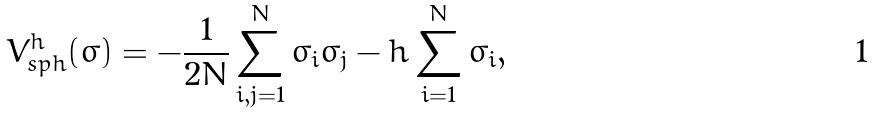<formula> <loc_0><loc_0><loc_500><loc_500>V ^ { h } _ { s p h } ( \sigma ) = - \frac { 1 } { 2 N } \sum _ { i , j = 1 } ^ { N } \sigma _ { i } \sigma _ { j } - h \sum _ { i = 1 } ^ { N } \sigma _ { i } ,</formula> 